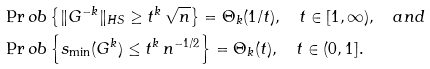Convert formula to latex. <formula><loc_0><loc_0><loc_500><loc_500>& \Pr o b \left \{ \| G ^ { - k } \| _ { H S } \geq t ^ { k } \, \sqrt { n } \right \} = \Theta _ { k } ( 1 / t ) , \quad t \in [ 1 , \infty ) , \quad a n d \\ & \Pr o b \left \{ s _ { \min } ( G ^ { k } ) \leq t ^ { k } \, n ^ { - 1 / 2 } \right \} = \Theta _ { k } ( t ) , \quad t \in ( 0 , 1 ] .</formula> 